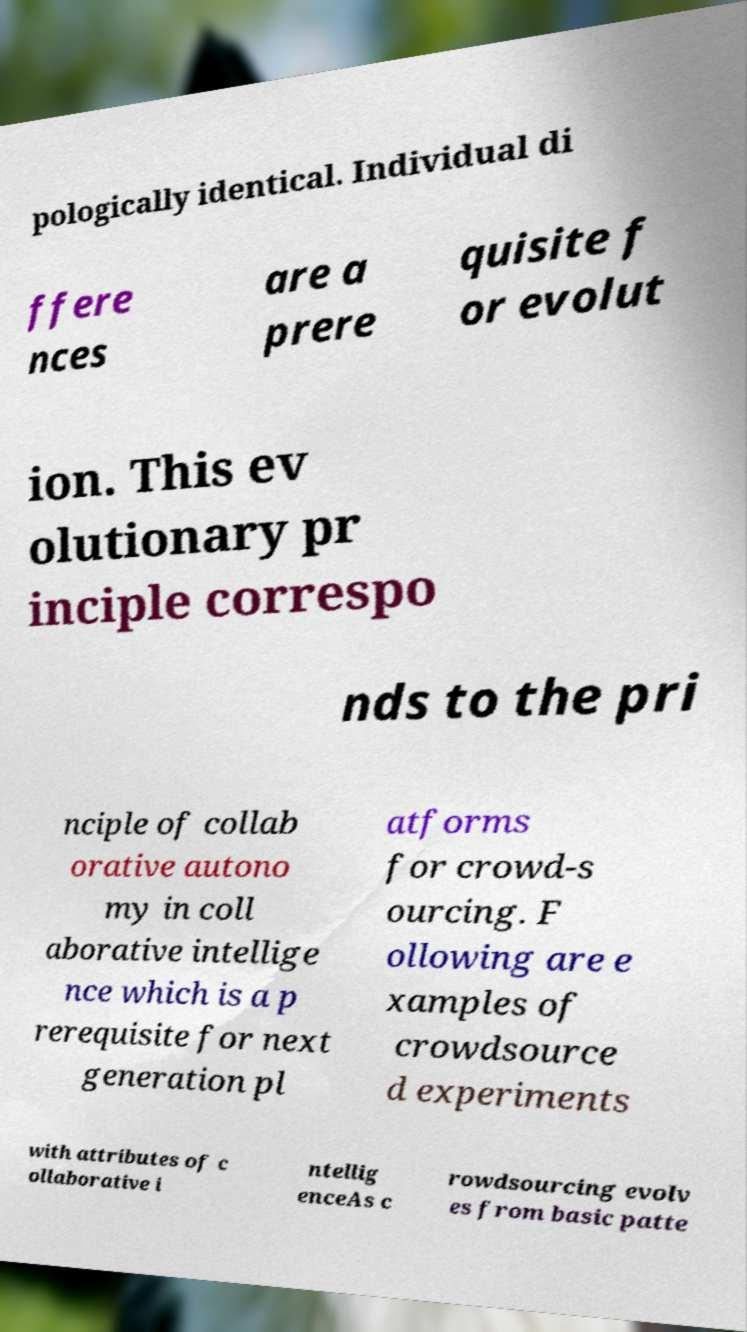Please identify and transcribe the text found in this image. pologically identical. Individual di ffere nces are a prere quisite f or evolut ion. This ev olutionary pr inciple correspo nds to the pri nciple of collab orative autono my in coll aborative intellige nce which is a p rerequisite for next generation pl atforms for crowd-s ourcing. F ollowing are e xamples of crowdsource d experiments with attributes of c ollaborative i ntellig enceAs c rowdsourcing evolv es from basic patte 